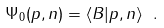Convert formula to latex. <formula><loc_0><loc_0><loc_500><loc_500>\Psi _ { 0 } ( p , n ) = \langle B | p , n \rangle \ .</formula> 